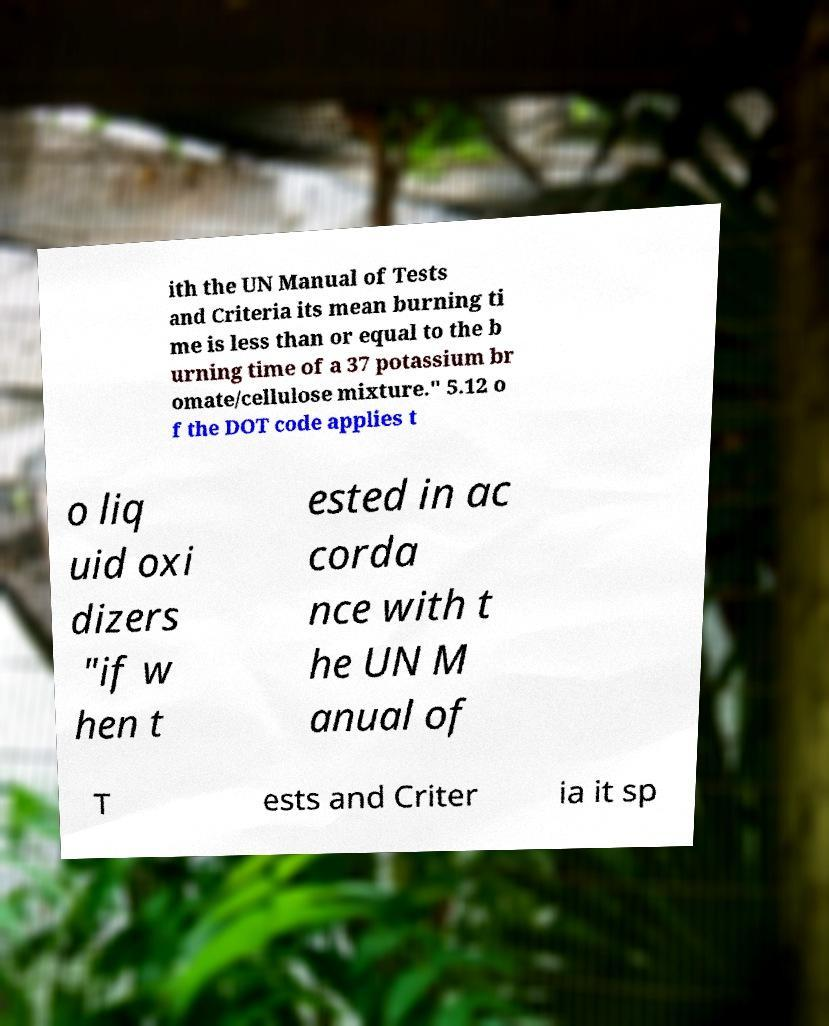I need the written content from this picture converted into text. Can you do that? ith the UN Manual of Tests and Criteria its mean burning ti me is less than or equal to the b urning time of a 37 potassium br omate/cellulose mixture." 5.12 o f the DOT code applies t o liq uid oxi dizers "if w hen t ested in ac corda nce with t he UN M anual of T ests and Criter ia it sp 